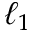<formula> <loc_0><loc_0><loc_500><loc_500>\ell _ { 1 }</formula> 